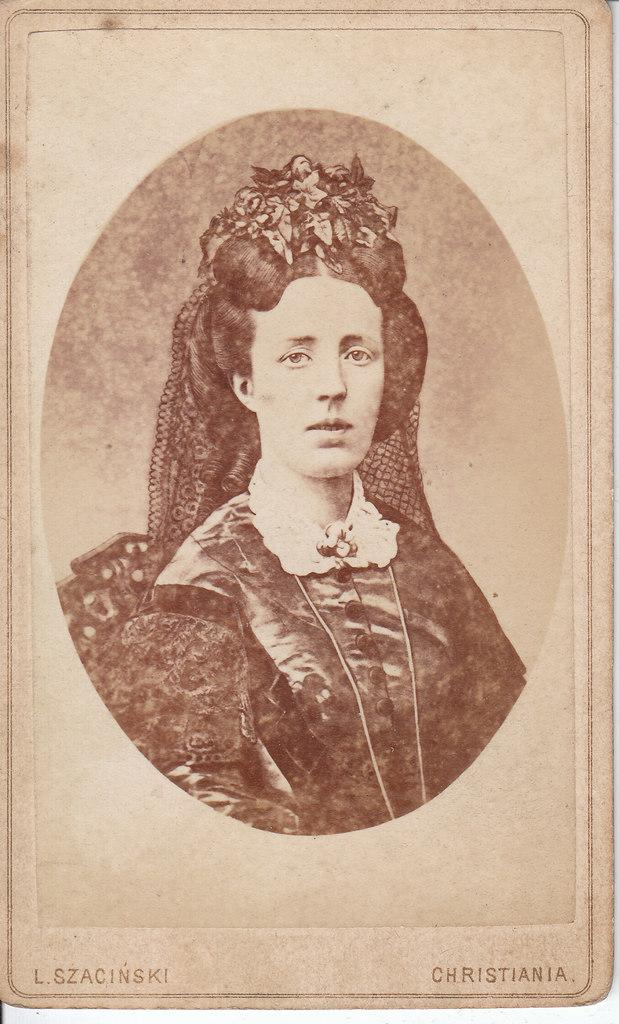What type of photo is in the image? The image contains a black and white photo of a lady. Can you describe any additional features of the photo? Text is written at the bottom of the image. What type of decision is the lady making in the image? There is no indication of a decision being made in the image, as it only contains a black and white photo of a lady and text at the bottom. 